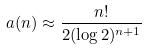<formula> <loc_0><loc_0><loc_500><loc_500>a ( n ) \approx \frac { n ! } { 2 ( \log 2 ) ^ { n + 1 } }</formula> 